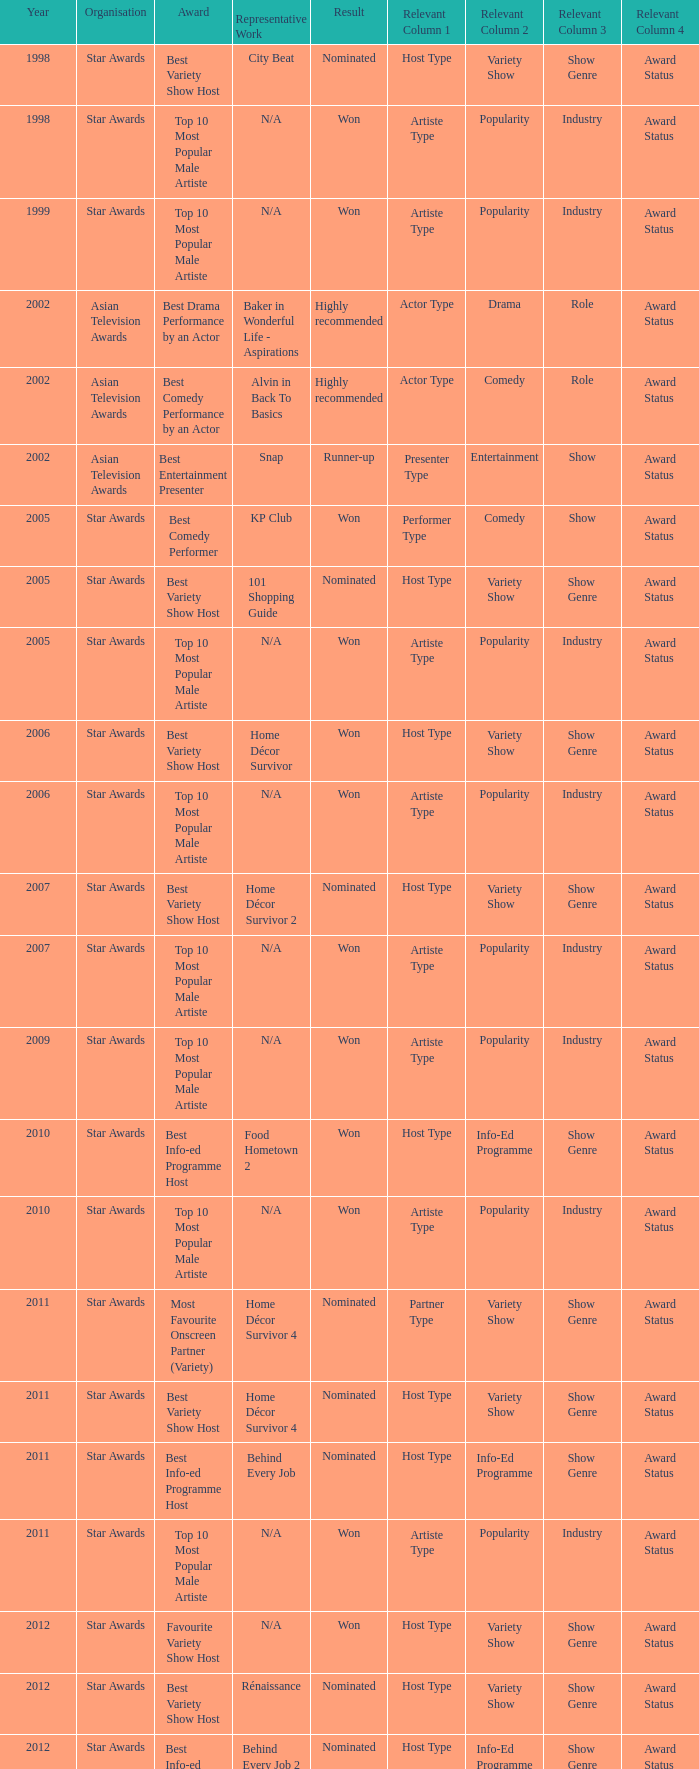What is the award for the Star Awards earlier than 2005 and the result is won? Top 10 Most Popular Male Artiste, Top 10 Most Popular Male Artiste. 